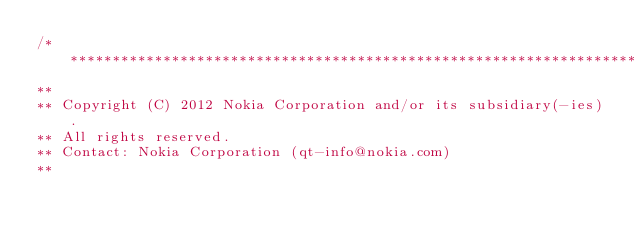Convert code to text. <code><loc_0><loc_0><loc_500><loc_500><_C_>/****************************************************************************
**
** Copyright (C) 2012 Nokia Corporation and/or its subsidiary(-ies).
** All rights reserved.
** Contact: Nokia Corporation (qt-info@nokia.com)
**</code> 